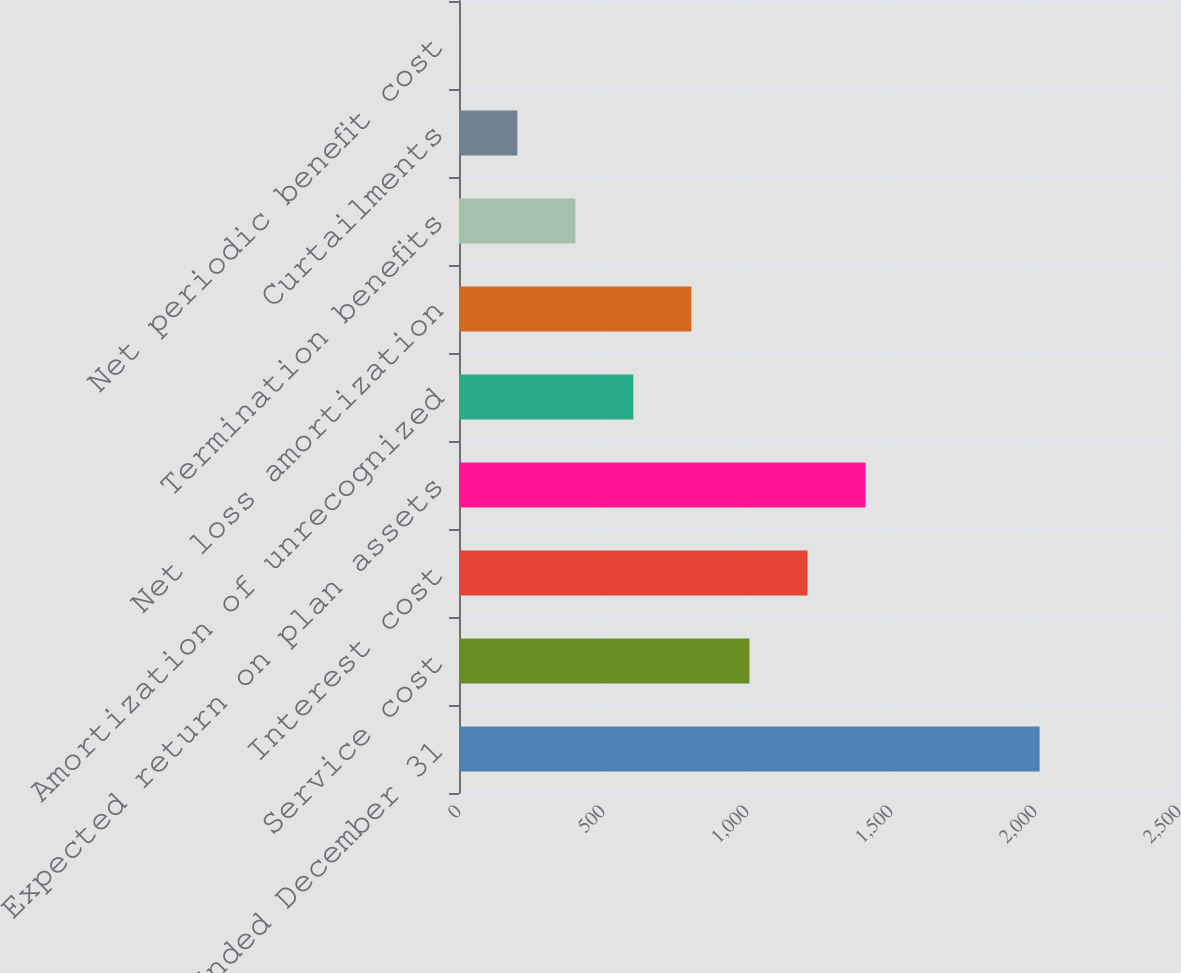<chart> <loc_0><loc_0><loc_500><loc_500><bar_chart><fcel>Years Ended December 31<fcel>Service cost<fcel>Interest cost<fcel>Expected return on plan assets<fcel>Amortization of unrecognized<fcel>Net loss amortization<fcel>Termination benefits<fcel>Curtailments<fcel>Net periodic benefit cost<nl><fcel>2016<fcel>1008.5<fcel>1210<fcel>1411.5<fcel>605.5<fcel>807<fcel>404<fcel>202.5<fcel>1<nl></chart> 